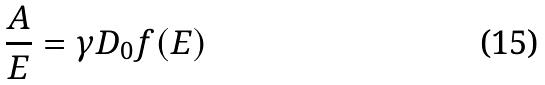<formula> <loc_0><loc_0><loc_500><loc_500>\frac { A } { E } = \gamma D _ { 0 } f ( E )</formula> 